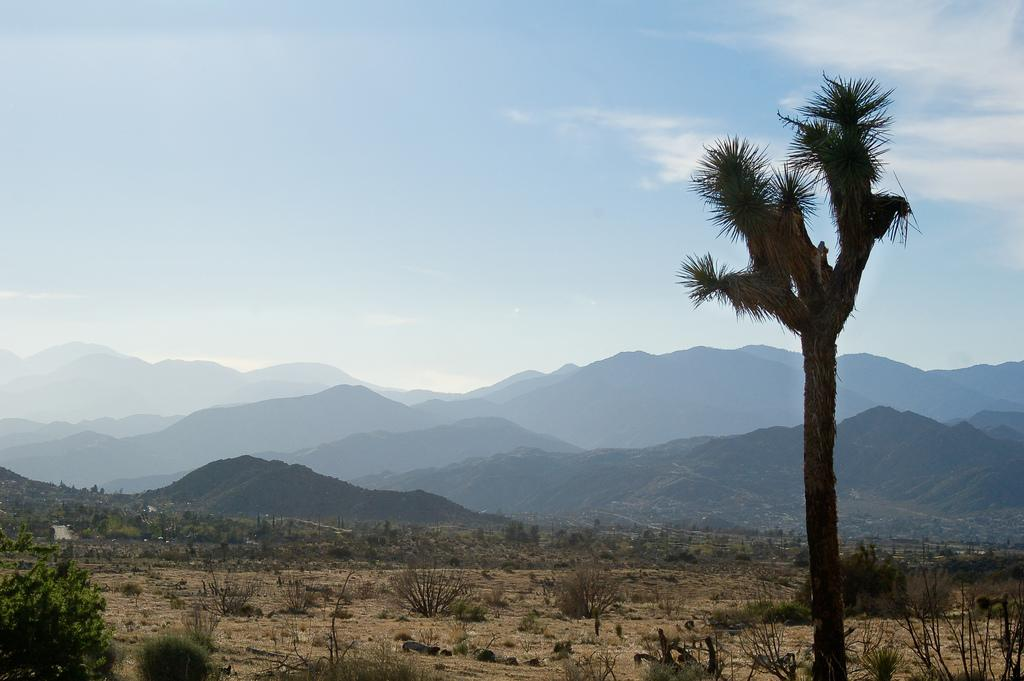What type of vegetation can be seen in the image? There are trees and small plants in the image. What type of geographical feature is visible in the image? There are mountains in the image. How would you describe the color of the sky in the image? The sky is a combination of white and blue colors in the image. How many jellyfish can be seen swimming in the image? There are no jellyfish present in the image. Can you compare the size of the trees to the mountains in the image? The provided facts do not include information about the size of the trees or mountains, so we cannot make a comparison. 